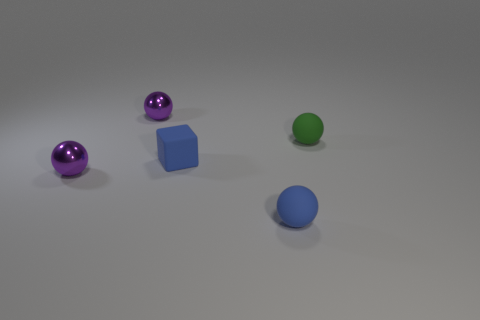Add 4 green things. How many objects exist? 9 Subtract all blocks. How many objects are left? 4 Subtract 0 brown blocks. How many objects are left? 5 Subtract all big red objects. Subtract all blue rubber cubes. How many objects are left? 4 Add 5 cubes. How many cubes are left? 6 Add 2 metallic balls. How many metallic balls exist? 4 